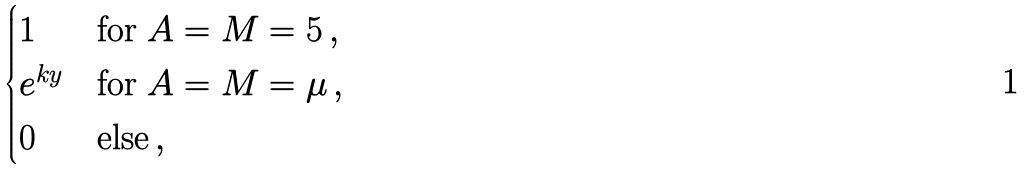Convert formula to latex. <formula><loc_0><loc_0><loc_500><loc_500>\begin{cases} 1 & \text {for } A = M = 5 \, , \\ e ^ { k y } & \text {for } A = M = \mu \, , \\ 0 & \text {else} \, , \end{cases}</formula> 